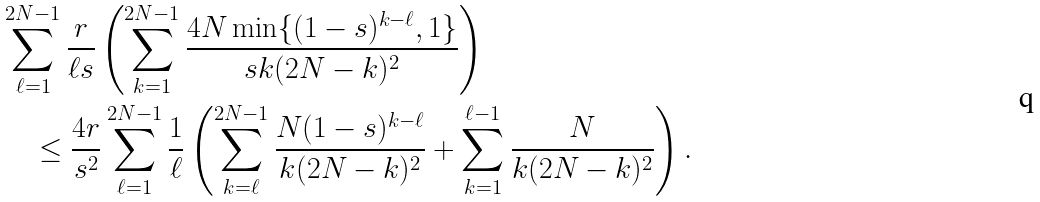Convert formula to latex. <formula><loc_0><loc_0><loc_500><loc_500>& \sum _ { \ell = 1 } ^ { 2 N - 1 } \frac { r } { \ell s } \left ( \sum _ { k = 1 } ^ { 2 N - 1 } \frac { 4 N \min \{ ( 1 - s ) ^ { k - \ell } , 1 \} } { s k ( 2 N - k ) ^ { 2 } } \right ) \\ & \quad \leq \frac { 4 r } { s ^ { 2 } } \sum _ { \ell = 1 } ^ { 2 N - 1 } \frac { 1 } { \ell } \left ( \sum _ { k = \ell } ^ { 2 N - 1 } \frac { N ( 1 - s ) ^ { k - \ell } } { k ( 2 N - k ) ^ { 2 } } + \sum _ { k = 1 } ^ { \ell - 1 } \frac { N } { k ( 2 N - k ) ^ { 2 } } \right ) .</formula> 